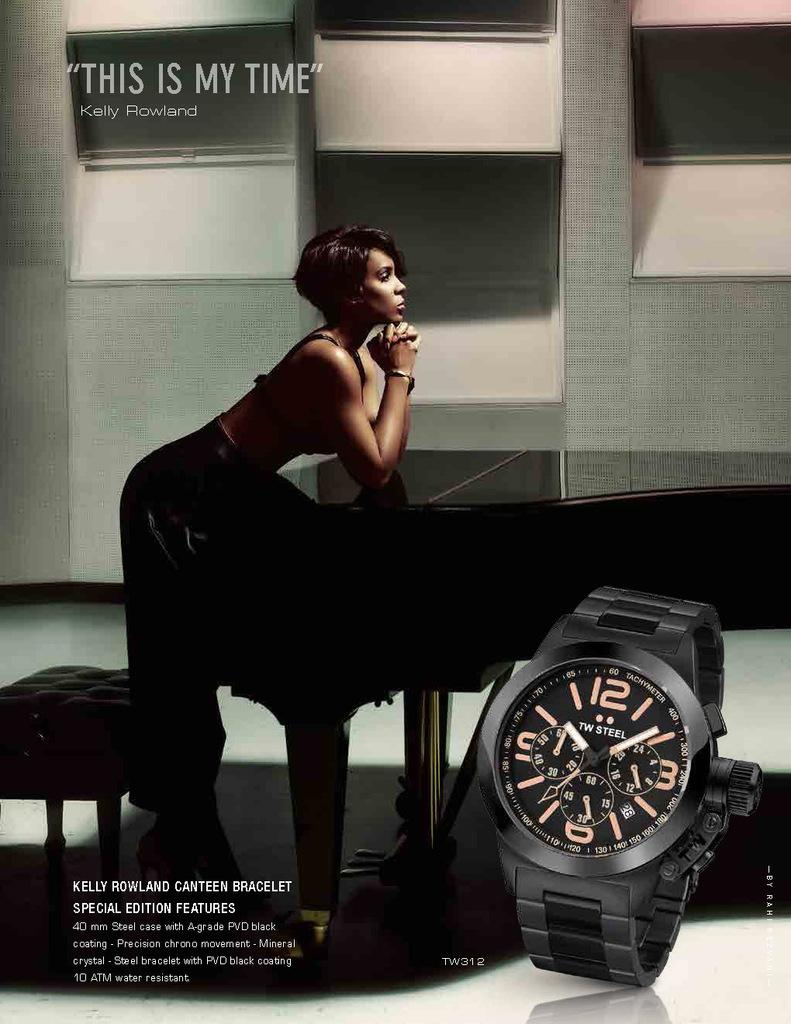<image>
Give a short and clear explanation of the subsequent image. Kelly Rowlands says that "this is my time". 